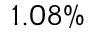Convert formula to latex. <formula><loc_0><loc_0><loc_500><loc_500>1 . 0 8 \%</formula> 